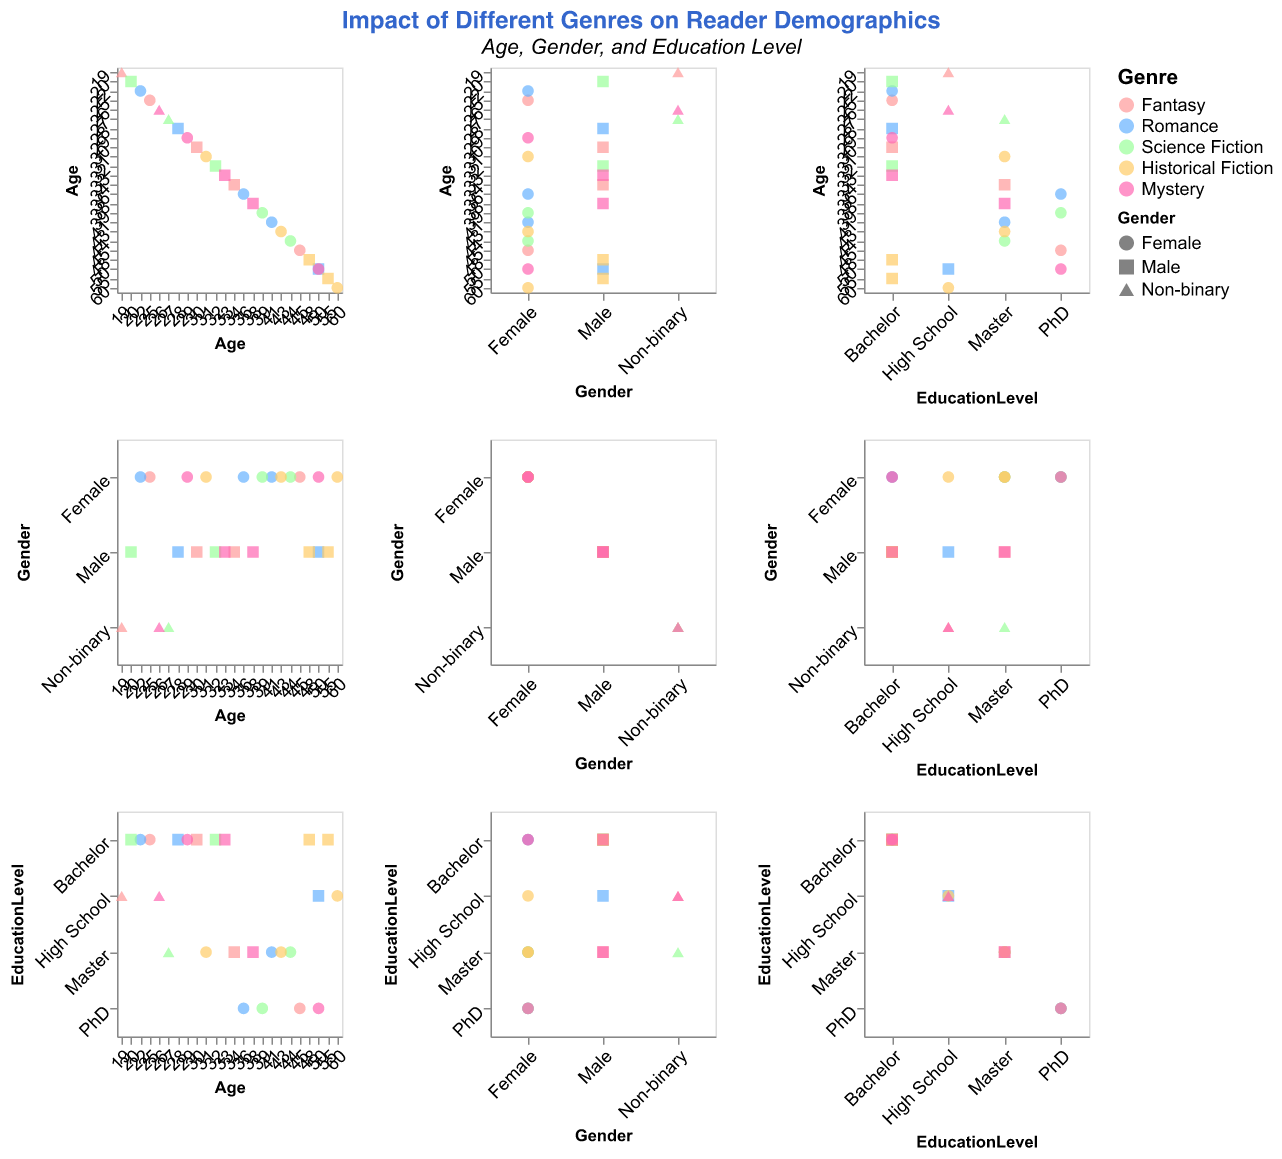What is the title of the figure? The title of the figure can be found at the top, generally in larger and bold font, making it the most prominent text in the visualization.
Answer: Impact of Different Genres on Reader Demographics Which genre has the most diverse range of occupations? To determine the genre with the most diverse range of occupations, look at the variety of occupations listed for each genre in the scatter plot matrix.
Answer: Fantasy What is the age range of readers who prefer Science Fiction? To determine the age range, find the minimum and maximum ages of the readers who prefer Science Fiction in the scatter plot.
Answer: 20 to 44 Which gender is most represented among Romance readers? By examining the shapes used to represent different genders for Romance readers, identify the most common shape.
Answer: Female How does the education level distribution of Fantasy readers compare to that of Mystery readers? Compare the different education levels depicted for Fantasy and Mystery genres, observing the variety and frequencies of each education level.
Answer: Fantasy readers have a higher diversity in education levels, including High School, Bachelor, Master, and PhD, with Fantasy even having more PhD readers compared to Mystery What is the most common occupation for readers of Historical Fiction? Look for the occupation that appears most frequently among Historical Fiction readers in the scatter plot.
Answer: Teacher How does the average age of Male Science Fiction readers compare to Female Science Fiction readers? To find this, calculate the average age for male and female Science Fiction readers separately and compare the two averages.
Answer: Male (31.5), Female (41.5) Which genre appears to be favored by older readers? Identify the genre whose data points, representing age, indicate higher average ages.
Answer: Historical Fiction What is the gender distribution among the readers of Mystery? Count the occurrences of each gender within the Mystery genre by the different shapes used to represent genders.
Answer: 3 Females, 2 Males, 1 Non-binary What proportion of Romance readers with a Bachelor's degree are male? Calculate the percentage by dividing the number of male Romance readers with a Bachelor's degree by the total number of Romance readers with a Bachelor's degree and multiplying by 100.
Answer: 33.3% 